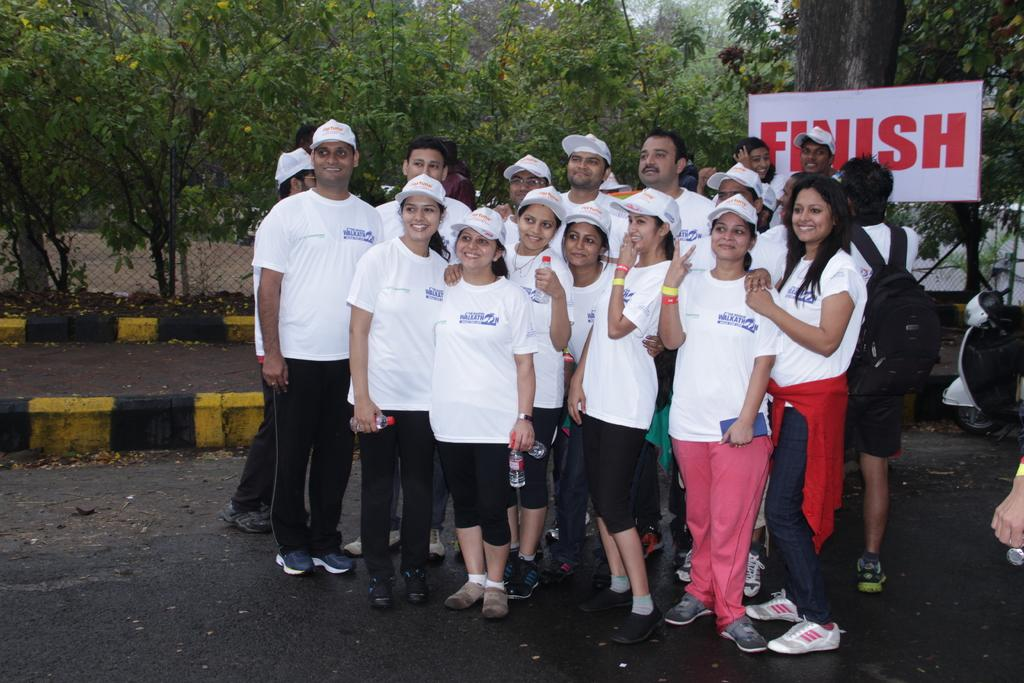How many people are in the image? There is a group of people in the image, but the exact number is not specified. What are the people wearing in the image? The people are wearing white shirts and black pants in the image. What can be seen in the background of the image? There is a white color banner and trees in the background, and the trees are green. The sky is also visible in the background, and it is white. What type of engine is being used by the guide in the image? There is no guide or engine present in the image. The people are wearing white shirts and black pants, and there is a white color banner, trees, and a white sky in the background. 